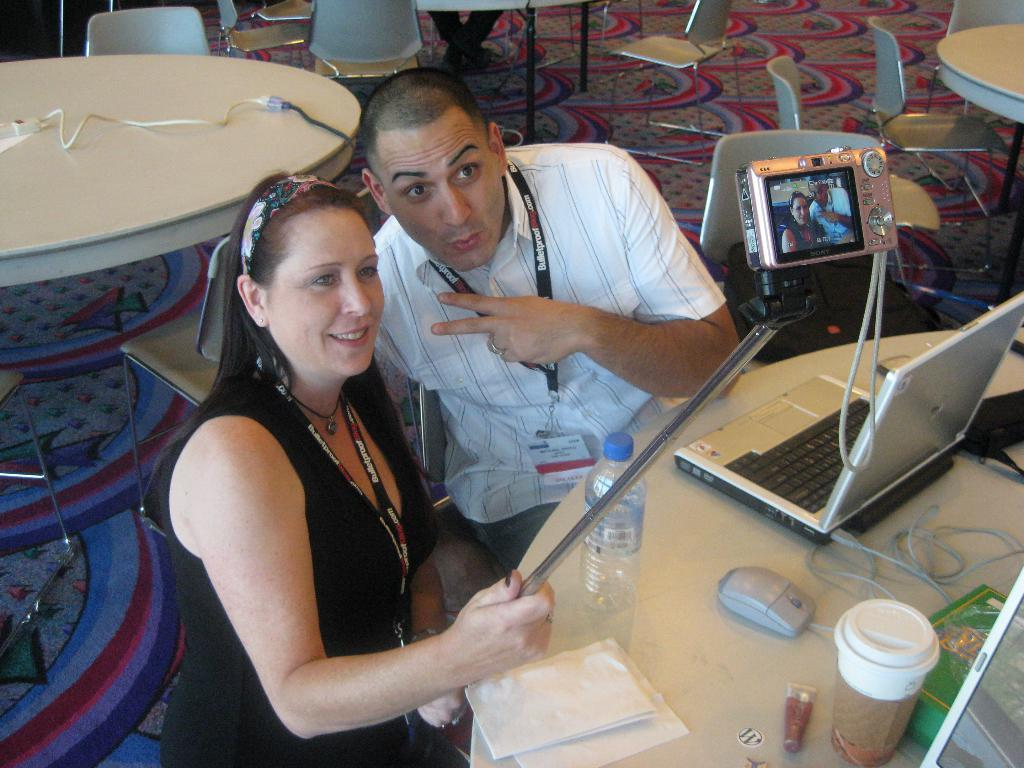How many people are in the image? There are two people in the image, a man and a woman. What are the man and the woman wearing? Both the man and the woman are wearing a black tag. What expressions do the man and the woman have? Both the man and the woman are smiling. What is on the table in the image? There is a laptop and a coffee cup on the table. What type of acoustics can be heard in the image? There is no audio or sound present in the image, so it is not possible to determine the acoustics. --- Facts: 1. There is a car in the image. 2. The car is red. 3. The car has four wheels. 4. There is a road in the image. 5. The road is paved. 6. There are trees in the background of the image. Absurd Topics: parrot, sand, dance Conversation: What is the main subject of the image? The main subject of the image is a car. What color is the car? The car is red. How many wheels does the car have? The car has four wheels. What is the surface of the road in the image? The road is paved. What can be seen in the background of the image? There are trees in the background of the image. Reasoning: Let's think step by step in order to produce the conversation. We start by identifying the main subject of the image, which is the car. Then, we describe the car's appearance, focusing on its color and the number of wheels. Next, we mention the road and its surface, noting that it is paved. Finally, we describe the background, including the presence of trees. Absurd Question/Answer: Can you see a parrot dancing on the sand in the image? There is no parrot or sand present in the image; it features a red car on a paved road with trees in the background. 